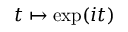<formula> <loc_0><loc_0><loc_500><loc_500>t \mapsto \exp ( i t )</formula> 